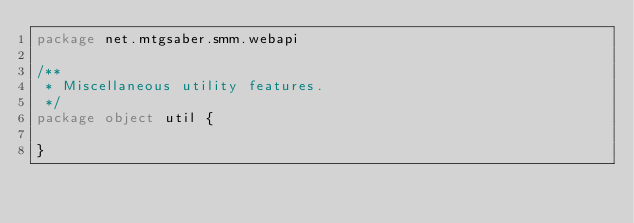Convert code to text. <code><loc_0><loc_0><loc_500><loc_500><_Scala_>package net.mtgsaber.smm.webapi

/**
 * Miscellaneous utility features.
 */
package object util {

}
</code> 